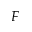<formula> <loc_0><loc_0><loc_500><loc_500>F</formula> 